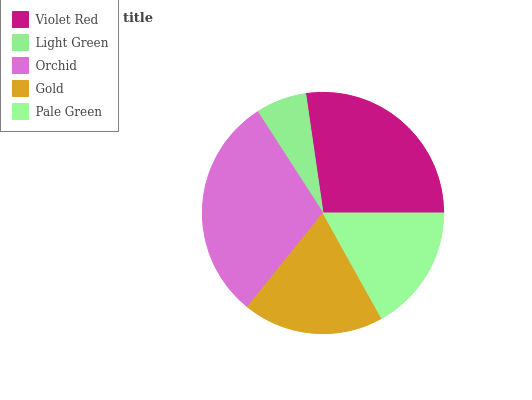Is Light Green the minimum?
Answer yes or no. Yes. Is Orchid the maximum?
Answer yes or no. Yes. Is Orchid the minimum?
Answer yes or no. No. Is Light Green the maximum?
Answer yes or no. No. Is Orchid greater than Light Green?
Answer yes or no. Yes. Is Light Green less than Orchid?
Answer yes or no. Yes. Is Light Green greater than Orchid?
Answer yes or no. No. Is Orchid less than Light Green?
Answer yes or no. No. Is Gold the high median?
Answer yes or no. Yes. Is Gold the low median?
Answer yes or no. Yes. Is Violet Red the high median?
Answer yes or no. No. Is Violet Red the low median?
Answer yes or no. No. 